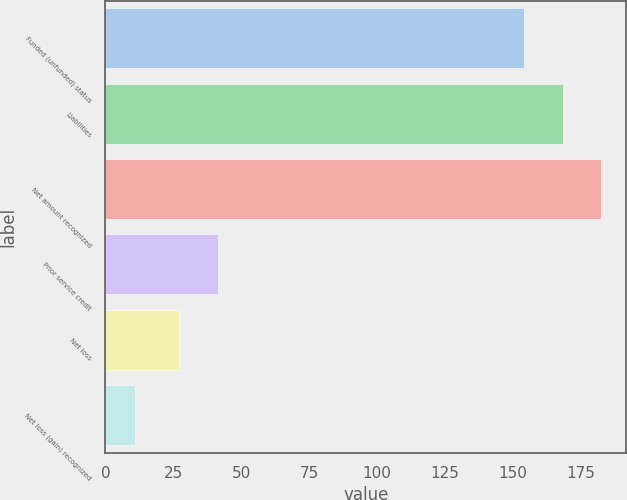<chart> <loc_0><loc_0><loc_500><loc_500><bar_chart><fcel>Funded (unfunded) status<fcel>Liabilities<fcel>Net amount recognized<fcel>Prior service credit<fcel>Net loss<fcel>Net loss (gain) recognized<nl><fcel>154<fcel>168.3<fcel>182.6<fcel>41.3<fcel>27<fcel>11<nl></chart> 